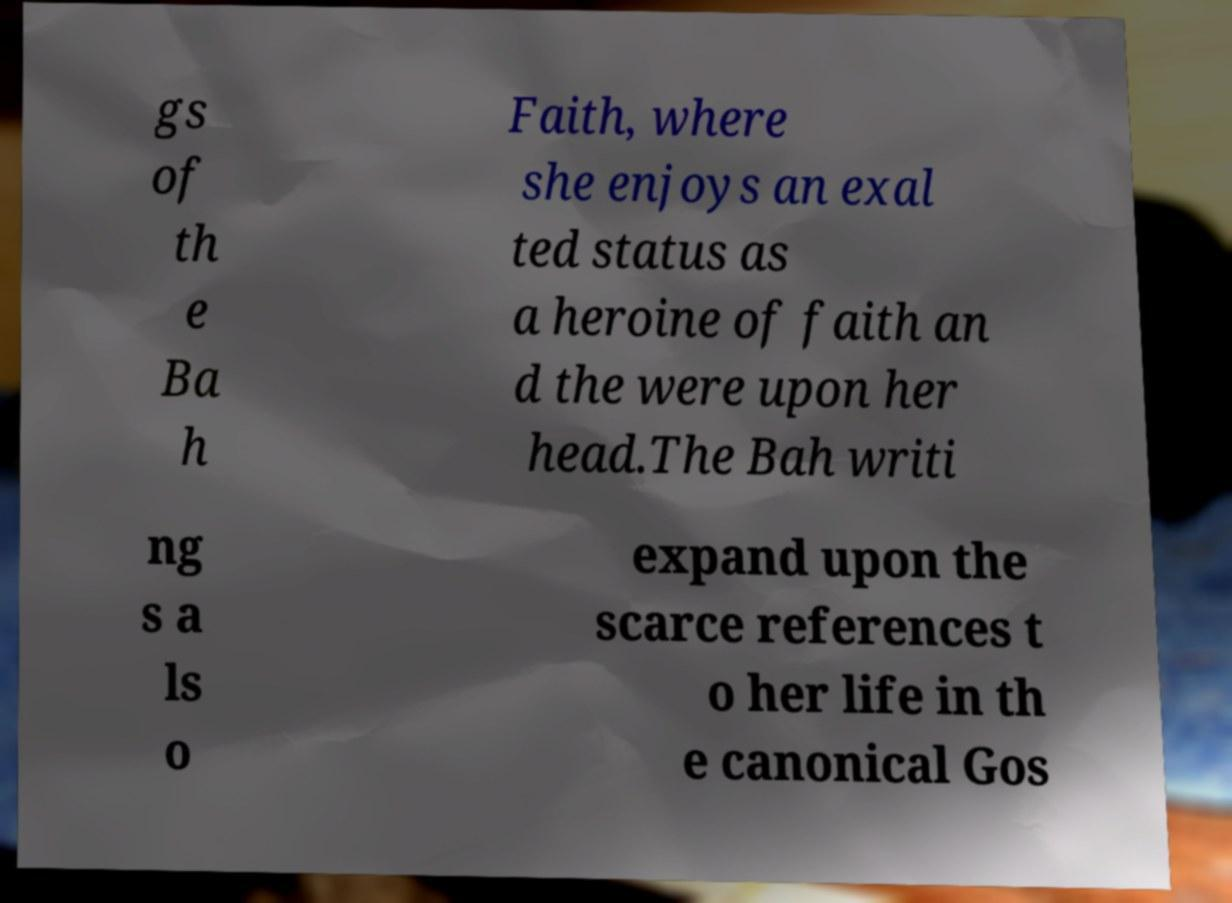Please read and relay the text visible in this image. What does it say? gs of th e Ba h Faith, where she enjoys an exal ted status as a heroine of faith an d the were upon her head.The Bah writi ng s a ls o expand upon the scarce references t o her life in th e canonical Gos 